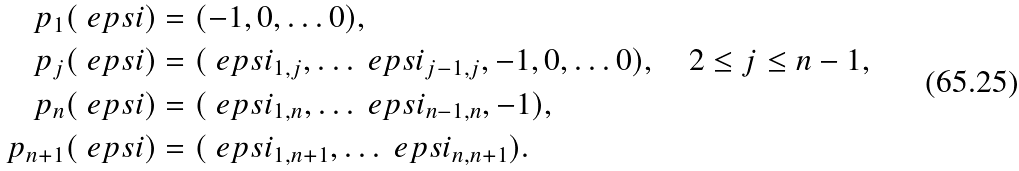Convert formula to latex. <formula><loc_0><loc_0><loc_500><loc_500>p _ { 1 } ( \ e p s i ) & = ( - 1 , 0 , \dots 0 ) , \\ p _ { j } ( \ e p s i ) & = ( \ e p s i _ { 1 , j } , \dots \ e p s i _ { j - 1 , j } , - 1 , 0 , \dots 0 ) , \quad 2 \leq j \leq n - 1 , \\ p _ { n } ( \ e p s i ) & = ( \ e p s i _ { 1 , n } , \dots \ e p s i _ { n - 1 , n } , - 1 ) , \\ p _ { n + 1 } ( \ e p s i ) & = ( \ e p s i _ { 1 , n + 1 } , \dots \ e p s i _ { n , n + 1 } ) .</formula> 